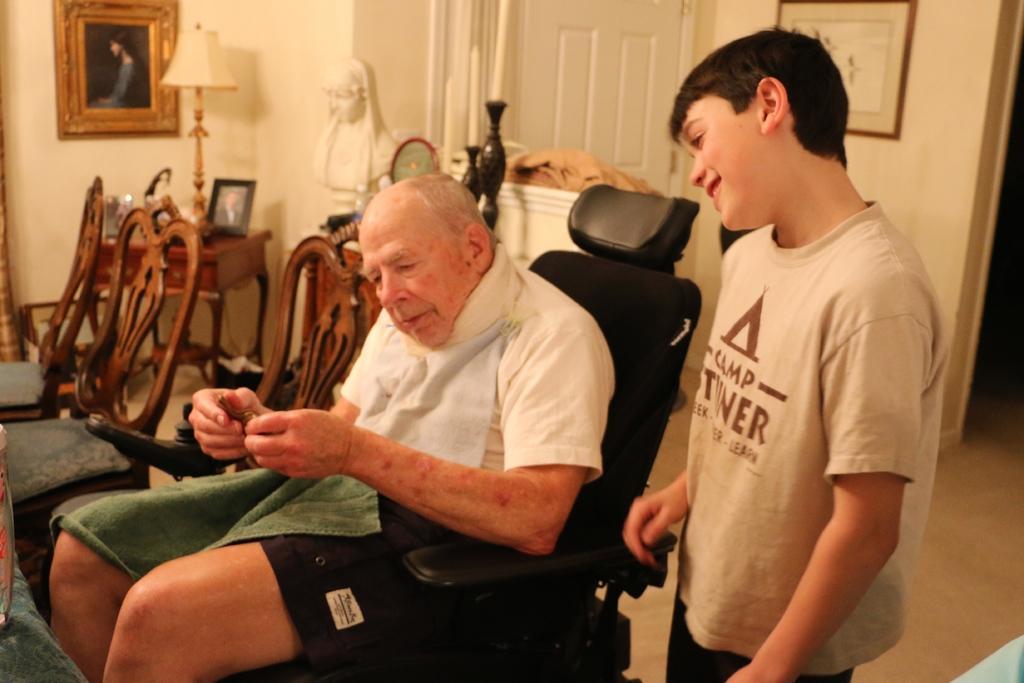Could you give a brief overview of what you see in this image? In this image we can see a man sitting on a chair. We can also see a cloth on his lap and a child standing beside him. On the backside we can see some chairs, a table containing a lamp and a photo frame on it, the sculpture, a door and some photo frames on a wall. On the left bottom we can see an object placed on the surface. 